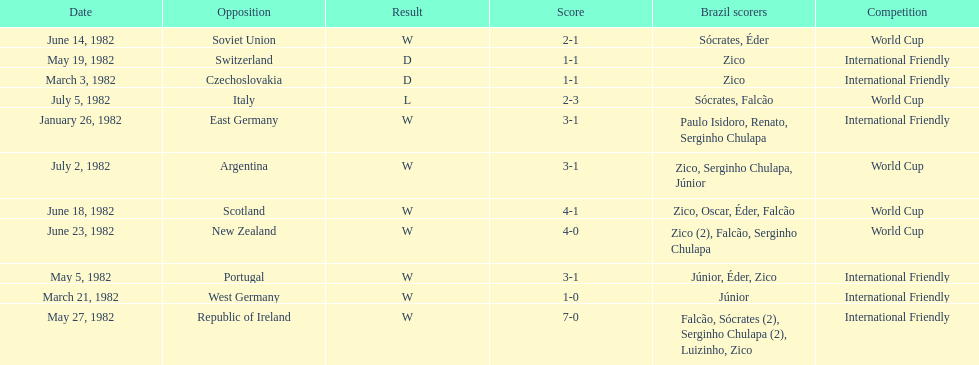How many games did zico end up scoring in during this season? 7. 